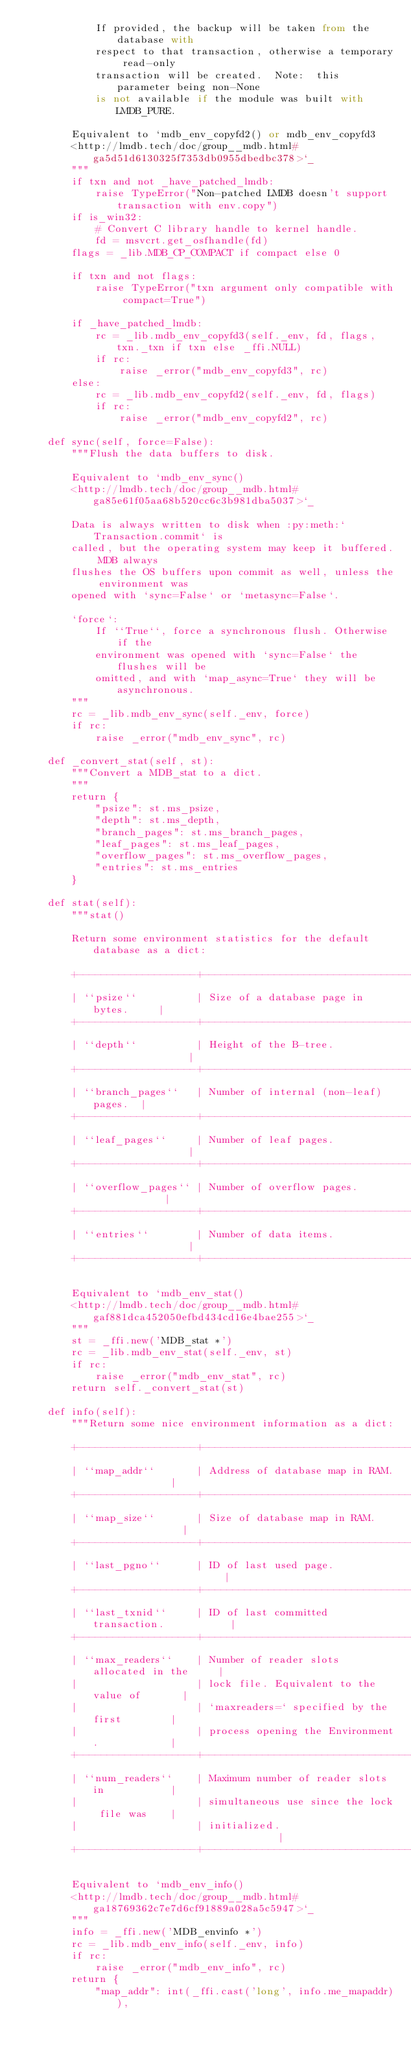Convert code to text. <code><loc_0><loc_0><loc_500><loc_500><_Python_>            If provided, the backup will be taken from the database with
            respect to that transaction, otherwise a temporary read-only
            transaction will be created.  Note:  this parameter being non-None
            is not available if the module was built with LMDB_PURE.

        Equivalent to `mdb_env_copyfd2() or mdb_env_copyfd3
        <http://lmdb.tech/doc/group__mdb.html#ga5d51d6130325f7353db0955dbedbc378>`_
        """
        if txn and not _have_patched_lmdb:
            raise TypeError("Non-patched LMDB doesn't support transaction with env.copy")
        if is_win32:
            # Convert C library handle to kernel handle.
            fd = msvcrt.get_osfhandle(fd)
        flags = _lib.MDB_CP_COMPACT if compact else 0

        if txn and not flags:
            raise TypeError("txn argument only compatible with compact=True")

        if _have_patched_lmdb:
            rc = _lib.mdb_env_copyfd3(self._env, fd, flags, txn._txn if txn else _ffi.NULL)
            if rc:
                raise _error("mdb_env_copyfd3", rc)
        else:
            rc = _lib.mdb_env_copyfd2(self._env, fd, flags)
            if rc:
                raise _error("mdb_env_copyfd2", rc)

    def sync(self, force=False):
        """Flush the data buffers to disk.

        Equivalent to `mdb_env_sync()
        <http://lmdb.tech/doc/group__mdb.html#ga85e61f05aa68b520cc6c3b981dba5037>`_

        Data is always written to disk when :py:meth:`Transaction.commit` is
        called, but the operating system may keep it buffered. MDB always
        flushes the OS buffers upon commit as well, unless the environment was
        opened with `sync=False` or `metasync=False`.

        `force`:
            If ``True``, force a synchronous flush. Otherwise if the
            environment was opened with `sync=False` the flushes will be
            omitted, and with `map_async=True` they will be asynchronous.
        """
        rc = _lib.mdb_env_sync(self._env, force)
        if rc:
            raise _error("mdb_env_sync", rc)

    def _convert_stat(self, st):
        """Convert a MDB_stat to a dict.
        """
        return {
            "psize": st.ms_psize,
            "depth": st.ms_depth,
            "branch_pages": st.ms_branch_pages,
            "leaf_pages": st.ms_leaf_pages,
            "overflow_pages": st.ms_overflow_pages,
            "entries": st.ms_entries
        }

    def stat(self):
        """stat()

        Return some environment statistics for the default database as a dict:

        +--------------------+---------------------------------------+
        | ``psize``          | Size of a database page in bytes.     |
        +--------------------+---------------------------------------+
        | ``depth``          | Height of the B-tree.                 |
        +--------------------+---------------------------------------+
        | ``branch_pages``   | Number of internal (non-leaf) pages.  |
        +--------------------+---------------------------------------+
        | ``leaf_pages``     | Number of leaf pages.                 |
        +--------------------+---------------------------------------+
        | ``overflow_pages`` | Number of overflow pages.             |
        +--------------------+---------------------------------------+
        | ``entries``        | Number of data items.                 |
        +--------------------+---------------------------------------+

        Equivalent to `mdb_env_stat()
        <http://lmdb.tech/doc/group__mdb.html#gaf881dca452050efbd434cd16e4bae255>`_
        """
        st = _ffi.new('MDB_stat *')
        rc = _lib.mdb_env_stat(self._env, st)
        if rc:
            raise _error("mdb_env_stat", rc)
        return self._convert_stat(st)

    def info(self):
        """Return some nice environment information as a dict:

        +--------------------+---------------------------------------------+
        | ``map_addr``       | Address of database map in RAM.             |
        +--------------------+---------------------------------------------+
        | ``map_size``       | Size of database map in RAM.                |
        +--------------------+---------------------------------------------+
        | ``last_pgno``      | ID of last used page.                       |
        +--------------------+---------------------------------------------+
        | ``last_txnid``     | ID of last committed transaction.           |
        +--------------------+---------------------------------------------+
        | ``max_readers``    | Number of reader slots allocated in the     |
        |                    | lock file. Equivalent to the value of       |
        |                    | `maxreaders=` specified by the first        |
        |                    | process opening the Environment.            |
        +--------------------+---------------------------------------------+
        | ``num_readers``    | Maximum number of reader slots in           |
        |                    | simultaneous use since the lock file was    |
        |                    | initialized.                                |
        +--------------------+---------------------------------------------+

        Equivalent to `mdb_env_info()
        <http://lmdb.tech/doc/group__mdb.html#ga18769362c7e7d6cf91889a028a5c5947>`_
        """
        info = _ffi.new('MDB_envinfo *')
        rc = _lib.mdb_env_info(self._env, info)
        if rc:
            raise _error("mdb_env_info", rc)
        return {
            "map_addr": int(_ffi.cast('long', info.me_mapaddr)),</code> 